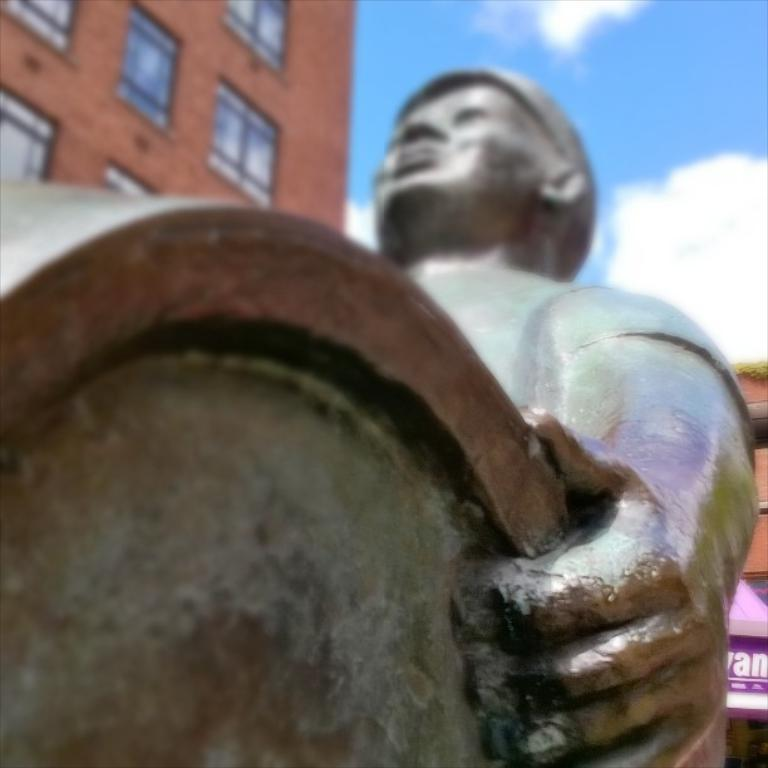Where was the image taken? The image was taken outside. What can be seen in the foreground of the image? There is a sculpture of a person holding an object in the foreground. What is visible in the background of the image? The sky and buildings are visible in the background. Can you describe any other elements in the background? There are other unspecified items in the background. How many rabbits are hopping around the sculpture in the image? There are no rabbits present in the image; it features a sculpture of a person holding an object. What suggestion does the clock in the image provide for the time of day? There is no clock present in the image, so it cannot provide any suggestion for the time of day. 